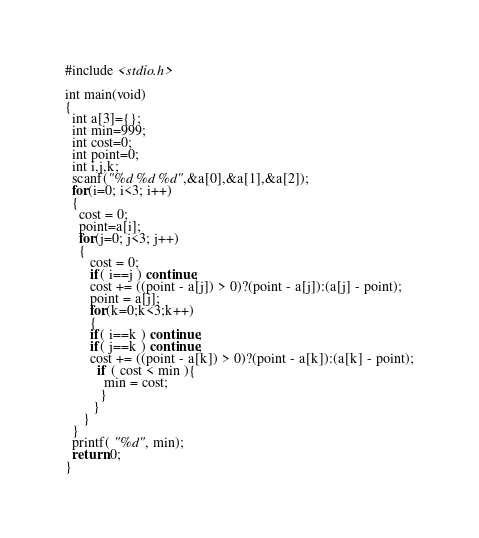Convert code to text. <code><loc_0><loc_0><loc_500><loc_500><_C_>#include <stdio.h>

int main(void)
{
  int a[3]={};
  int min=999;
  int cost=0;
  int point=0;
  int i,j,k;
  scanf("%d %d %d",&a[0],&a[1],&a[2]); 
  for(i=0; i<3; i++)
  {
    cost = 0;
    point=a[i];
    for(j=0; j<3; j++)
    {
       cost = 0;
       if( i==j ) continue;
       cost += ((point - a[j]) > 0)?(point - a[j]):(a[j] - point);
       point = a[j];
       for(k=0;k<3;k++)
       {
       if( i==k ) continue;
       if( j==k ) continue;
       cost += ((point - a[k]) > 0)?(point - a[k]):(a[k] - point);
         if ( cost < min ){
           min = cost;
          }
        }
     }
  }
  printf( "%d", min);
  return 0;
}</code> 